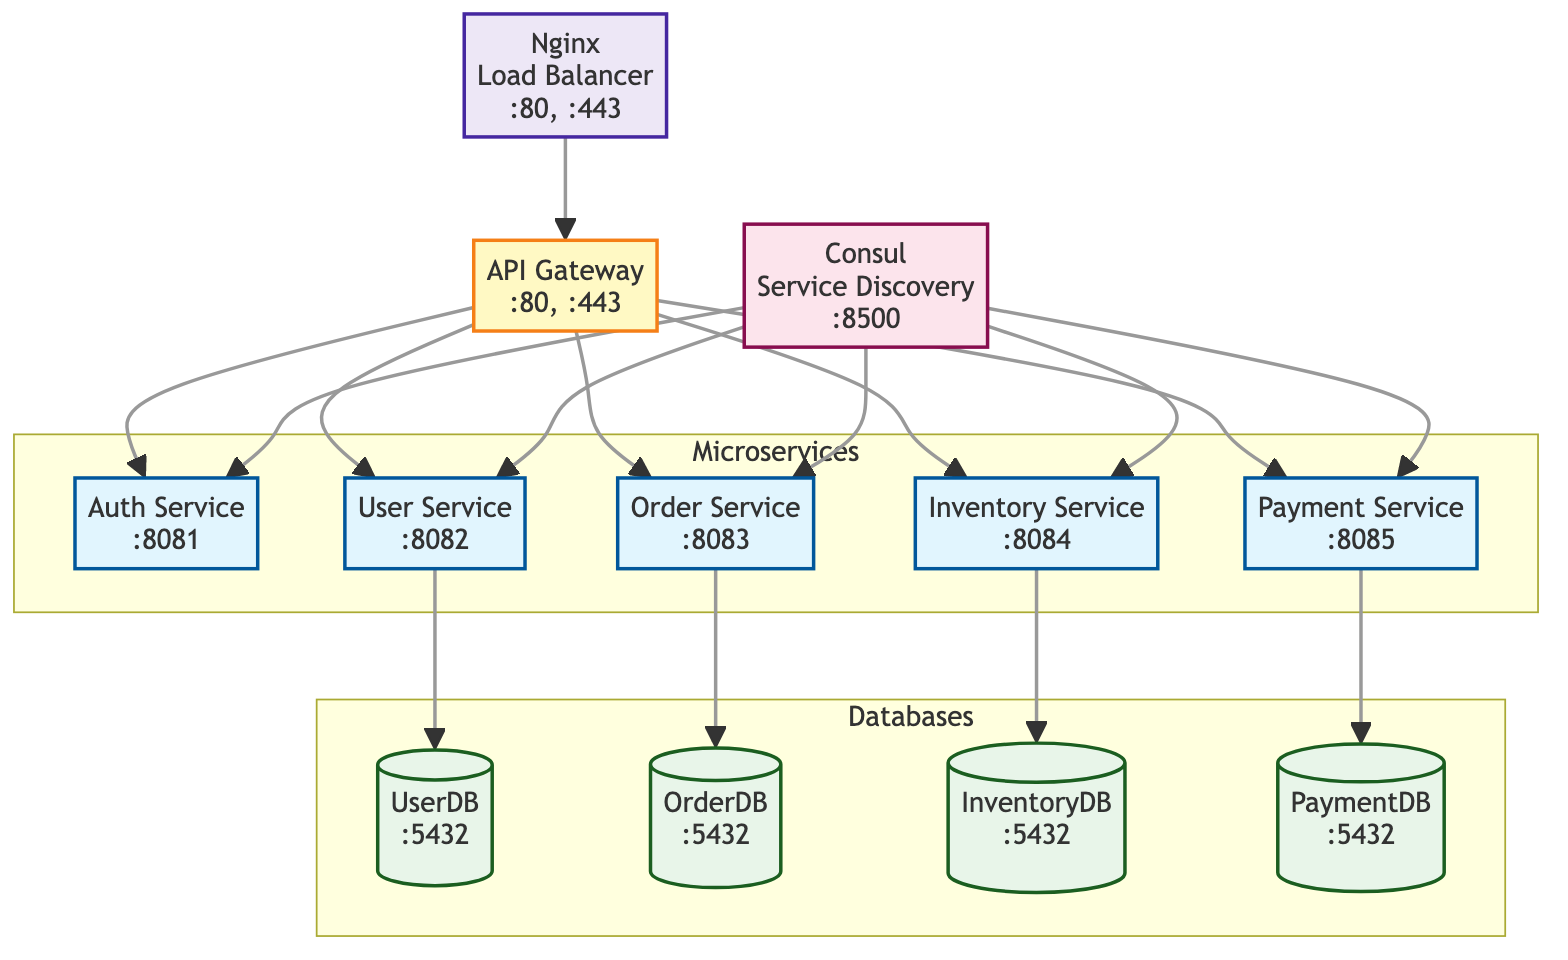What is the protocol used by the API Gateway? The API Gateway is listed in the diagram with the description that includes the protocol attribute, which is indicated as HTTP.
Answer: HTTP How many microservices are present in the diagram? The diagram shows a subgraph labeled "Microservices," which includes five microservices: Auth Service, User Service, Order Service, Inventory Service, and Payment Service. Counting these, we find there are five microservices.
Answer: 5 Which service communicates with the User Database? By tracing the arrows in the diagram, the User Service is directly connected to UserDB, indicating that it communicates with this database.
Answer: User Service What is the purpose of the Consul node in the diagram? The description next to the Consul node in the diagram indicates it serves as a service discovery and configuration tool, which clarifies its purpose.
Answer: Service Discovery How many ports are available for load balancing? The load balancer node indicates that it operates on two ports: 80 and 443, which can be counted directly from the node label.
Answer: 2 Which microservice is responsible for order management? The Order Service is specifically labeled in the diagram with a description that states it manages order-related operations, making it the responsible service for this task.
Answer: Order Service Do both the API Gateway and Load Balancer operate on the same ports? By examining the ports listed under both the API Gateway and the Load Balancer nodes, it's evident that both operate on ports 80 and 443, confirming that they use the same ports.
Answer: Yes What type of database is used for the Payment Service? The Payment Service is connected to the PaymentDB, which is characterized as a PostgreSQL database type based on the diagram's descriptions alongside the database node.
Answer: PostgreSQL Which service is the first point of contact for incoming requests? The diagram indicates that the Load Balancer connects directly to the API Gateway, making the API Gateway the first service to handle incoming requests.
Answer: API Gateway 